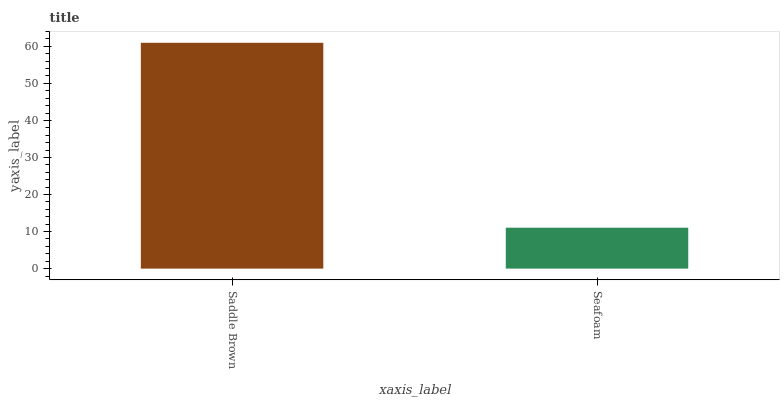Is Seafoam the minimum?
Answer yes or no. Yes. Is Saddle Brown the maximum?
Answer yes or no. Yes. Is Seafoam the maximum?
Answer yes or no. No. Is Saddle Brown greater than Seafoam?
Answer yes or no. Yes. Is Seafoam less than Saddle Brown?
Answer yes or no. Yes. Is Seafoam greater than Saddle Brown?
Answer yes or no. No. Is Saddle Brown less than Seafoam?
Answer yes or no. No. Is Saddle Brown the high median?
Answer yes or no. Yes. Is Seafoam the low median?
Answer yes or no. Yes. Is Seafoam the high median?
Answer yes or no. No. Is Saddle Brown the low median?
Answer yes or no. No. 